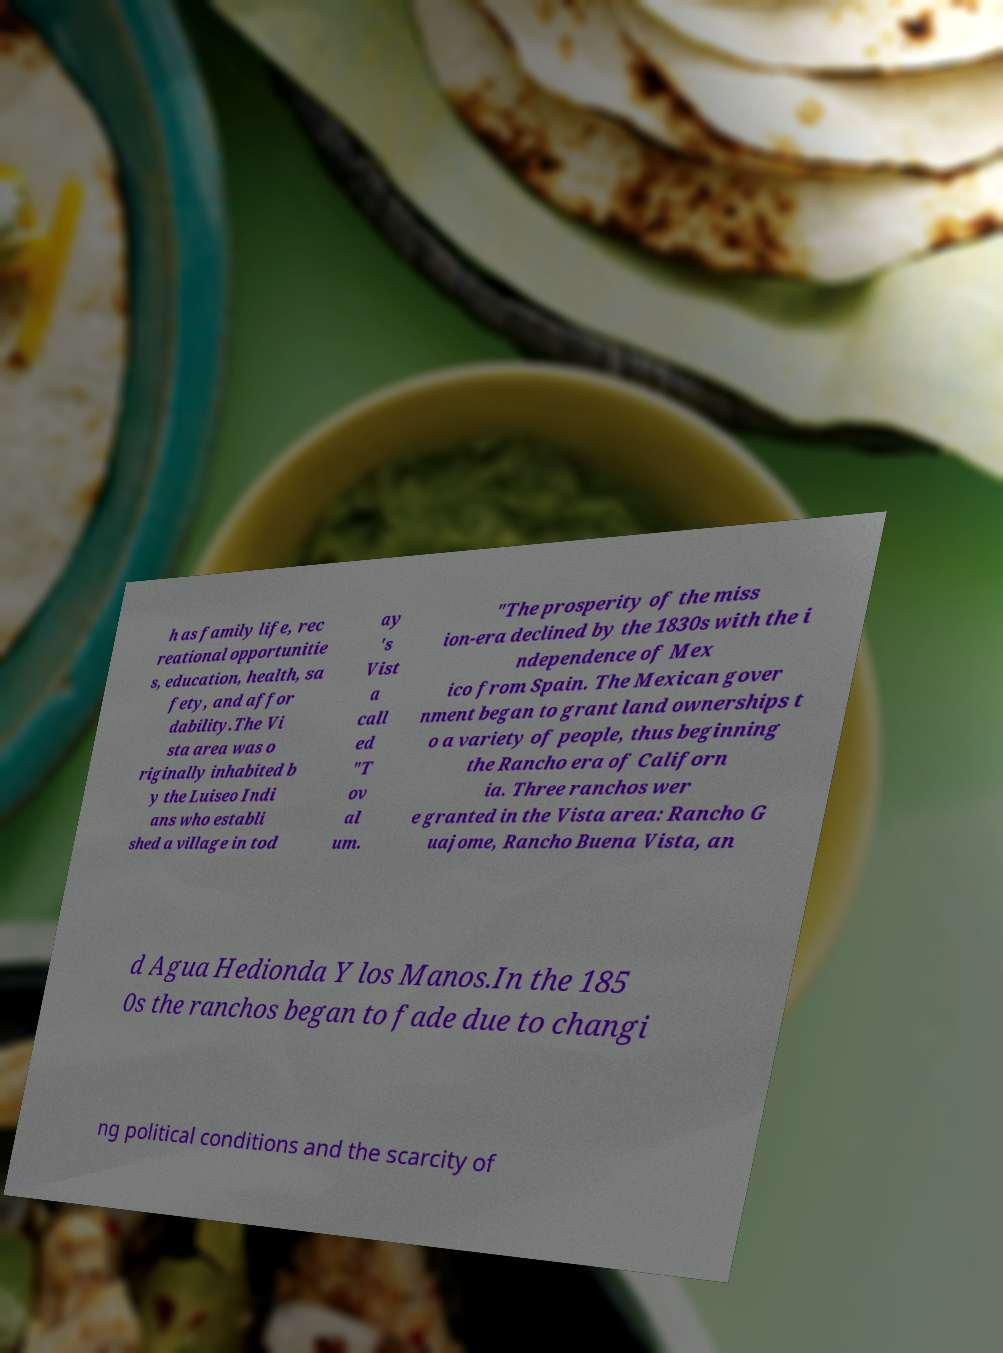Can you accurately transcribe the text from the provided image for me? h as family life, rec reational opportunitie s, education, health, sa fety, and affor dability.The Vi sta area was o riginally inhabited b y the Luiseo Indi ans who establi shed a village in tod ay 's Vist a call ed "T ov al um. "The prosperity of the miss ion-era declined by the 1830s with the i ndependence of Mex ico from Spain. The Mexican gover nment began to grant land ownerships t o a variety of people, thus beginning the Rancho era of Californ ia. Three ranchos wer e granted in the Vista area: Rancho G uajome, Rancho Buena Vista, an d Agua Hedionda Y los Manos.In the 185 0s the ranchos began to fade due to changi ng political conditions and the scarcity of 